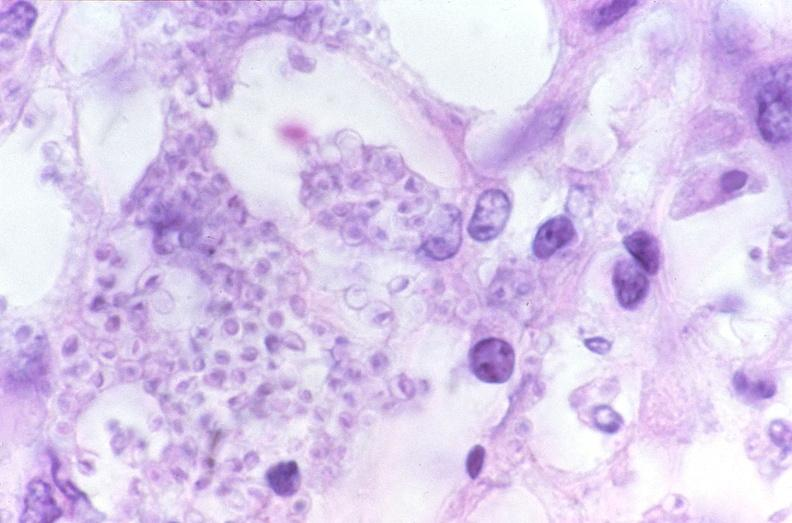does ulcer with candida infection show lung, histoplasma pneumonia?
Answer the question using a single word or phrase. No 